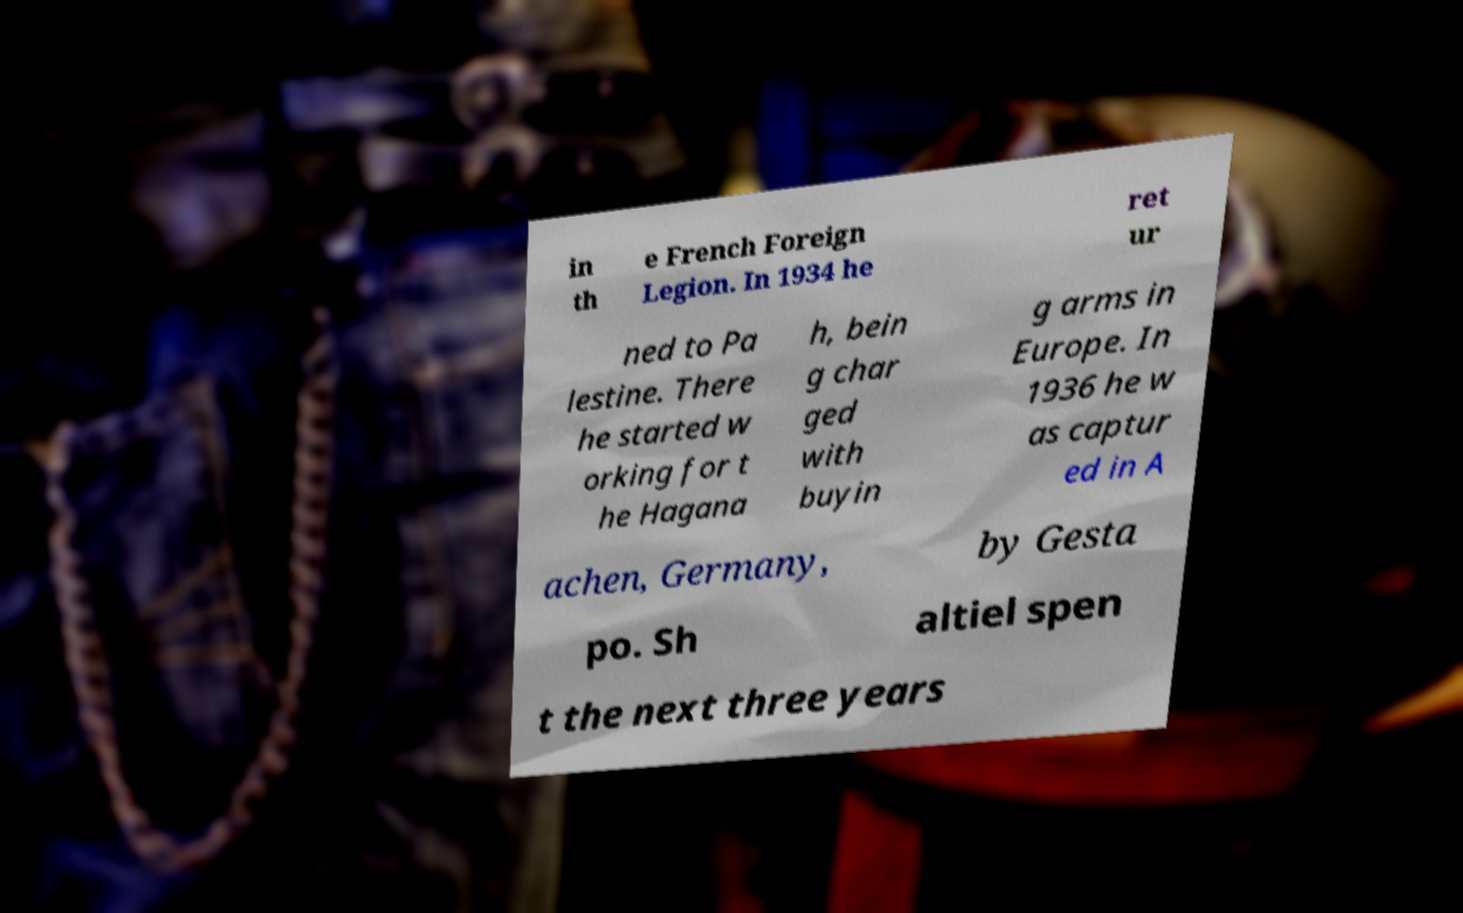Please read and relay the text visible in this image. What does it say? in th e French Foreign Legion. In 1934 he ret ur ned to Pa lestine. There he started w orking for t he Hagana h, bein g char ged with buyin g arms in Europe. In 1936 he w as captur ed in A achen, Germany, by Gesta po. Sh altiel spen t the next three years 